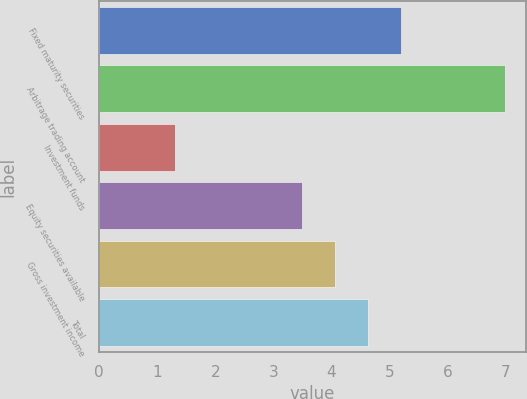Convert chart. <chart><loc_0><loc_0><loc_500><loc_500><bar_chart><fcel>Fixed maturity securities<fcel>Arbitrage trading account<fcel>Investment funds<fcel>Equity securities available<fcel>Gross investment income<fcel>Total<nl><fcel>5.21<fcel>7<fcel>1.3<fcel>3.5<fcel>4.07<fcel>4.64<nl></chart> 